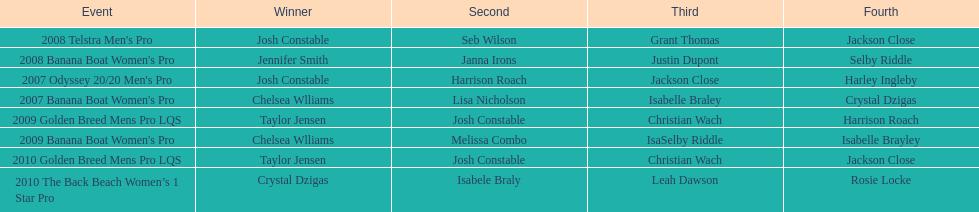How many times did josh constable finish as the second best? 2. 